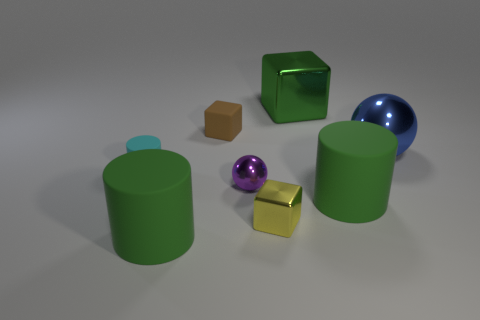Judging by the colors and arrangement, what kind of mood or setting does this collection of objects convey? The collection of objects has varied and vibrant colors, and their random arrangement gives an impression of a playful and casual setting, perhaps reminiscent of a child's play area or an educational setting for learning shapes and colors. 